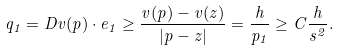<formula> <loc_0><loc_0><loc_500><loc_500>q _ { 1 } = D v ( p ) \cdot e _ { 1 } \geq \frac { v ( p ) - v ( z ) } { | p - z | } = \frac { h } { p _ { 1 } } \geq C \frac { h } { s ^ { 2 } } .</formula> 